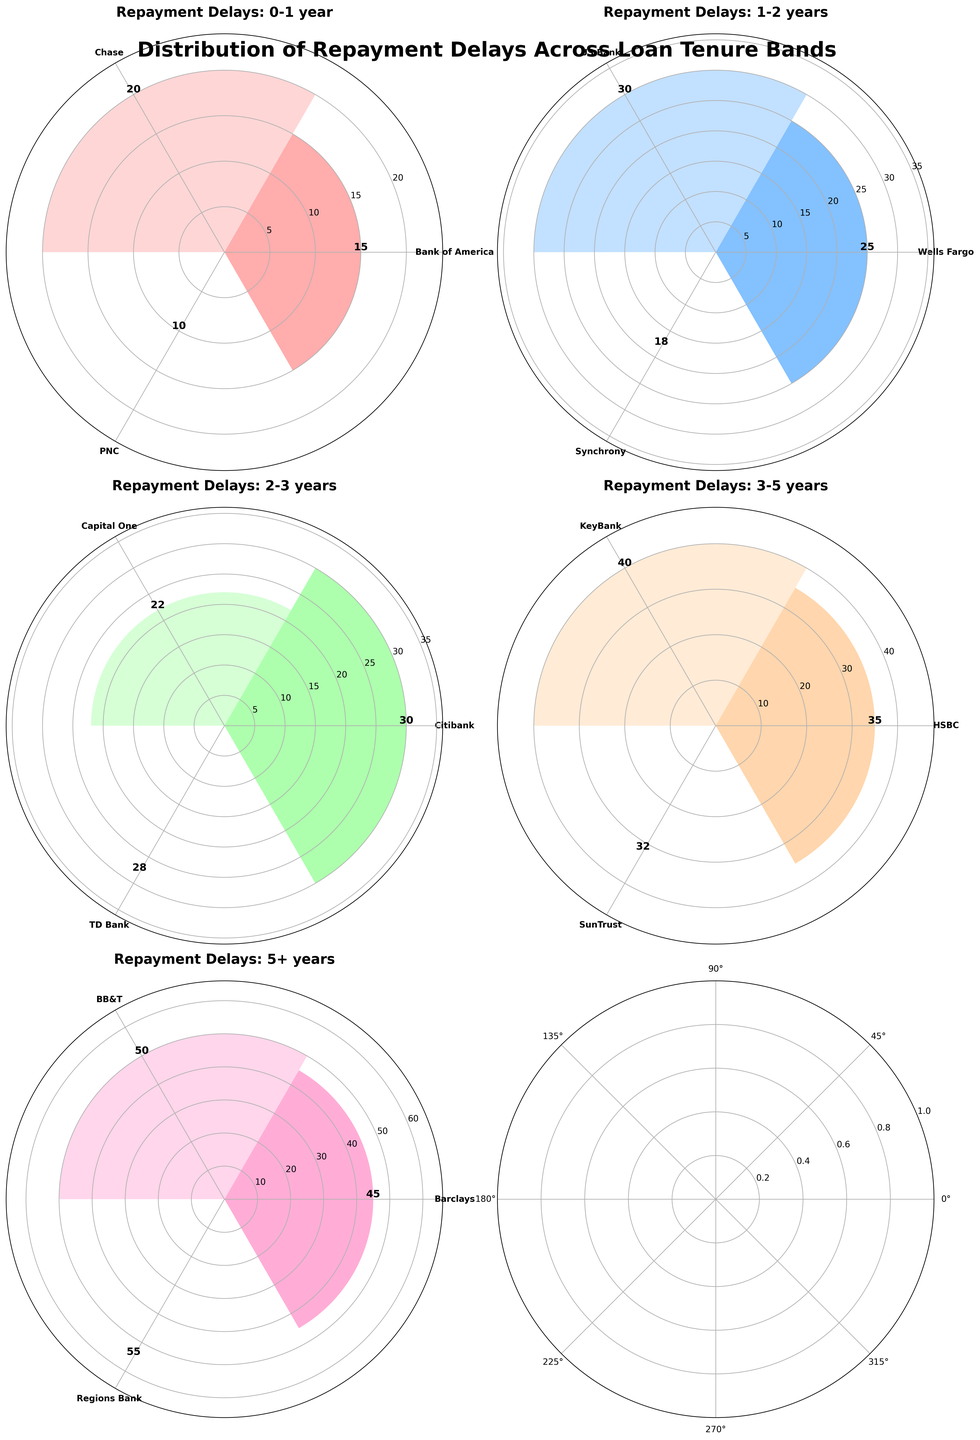Which loan tenure band has the highest number of repayment delays? By examining the figure, we can see that the loan tenure band with the most bars (longest bars) is "5+ years" with repayment delay counts of 45, 50, and 55.
Answer: 5+ years Which bank has the highest repayment delay count in the 0-1 year loan tenure band? The bar representing Bank of America, Chase, and PNC in the 0-1 year loan tenure band shows different heights. Chase has the tallest bar with a count of 20.
Answer: Chase How many banks have repayment delays in the 1-2 year loan tenure band? Each subplot focuses on a specific loan tenure band, and by counting the labeled bars in the 1-2 years band, we see there are 3 banks: Wells Fargo, US Bank, and Synchrony.
Answer: 3 Which bank has the shortest repayment delay count for the 2-3 year loan tenure band? In the 2-3 years loan tenure band, the shortest bar belongs to Capital One, with a count of 22.
Answer: Capital One What is the sum of repayment delays for the 3-5 year loan tenure band? To get the sum, we add the repayment delays for HSBC (35), KeyBank (40), and SunTrust (32). This gives 35 + 40 + 32 = 107.
Answer: 107 In which loan tenure band does BB&T fall, and what is its repayment delay count? Looking at the figure, BB&T is in the 5+ years band with a repayment delay count of 50.
Answer: 5+ years, 50 Which two banks have the closest repayment delay counts in the 3-5 year band? By examining the bars for the 3-5 years band, we see that HSBC (35) and SunTrust (32) have the closest counts, with a difference of only 3.
Answer: HSBC and SunTrust How does the repayment delay of PNC in the 0-1 year band compare to the repayment delay of US Bank in the 1-2 year band? PNC in the 0-1 year band has a delay count of 10, while US Bank in the 1-2 year band has a delay count of 30. US Bank's delays are higher.
Answer: US Bank > PNC What is the difference in repayment delay counts between Regions Bank and Barclays in the 5+ year band? Regions Bank has a count of 55, and Barclays has a count of 45. The difference is 55 - 45 = 10.
Answer: 10 Which bank has the most repayment delays in the 2-3 year band, and what is the count? By examining the bars in the 2-3 years band, Citibank has the highest repayment delay count with 30 delays.
Answer: Citibank, 30 